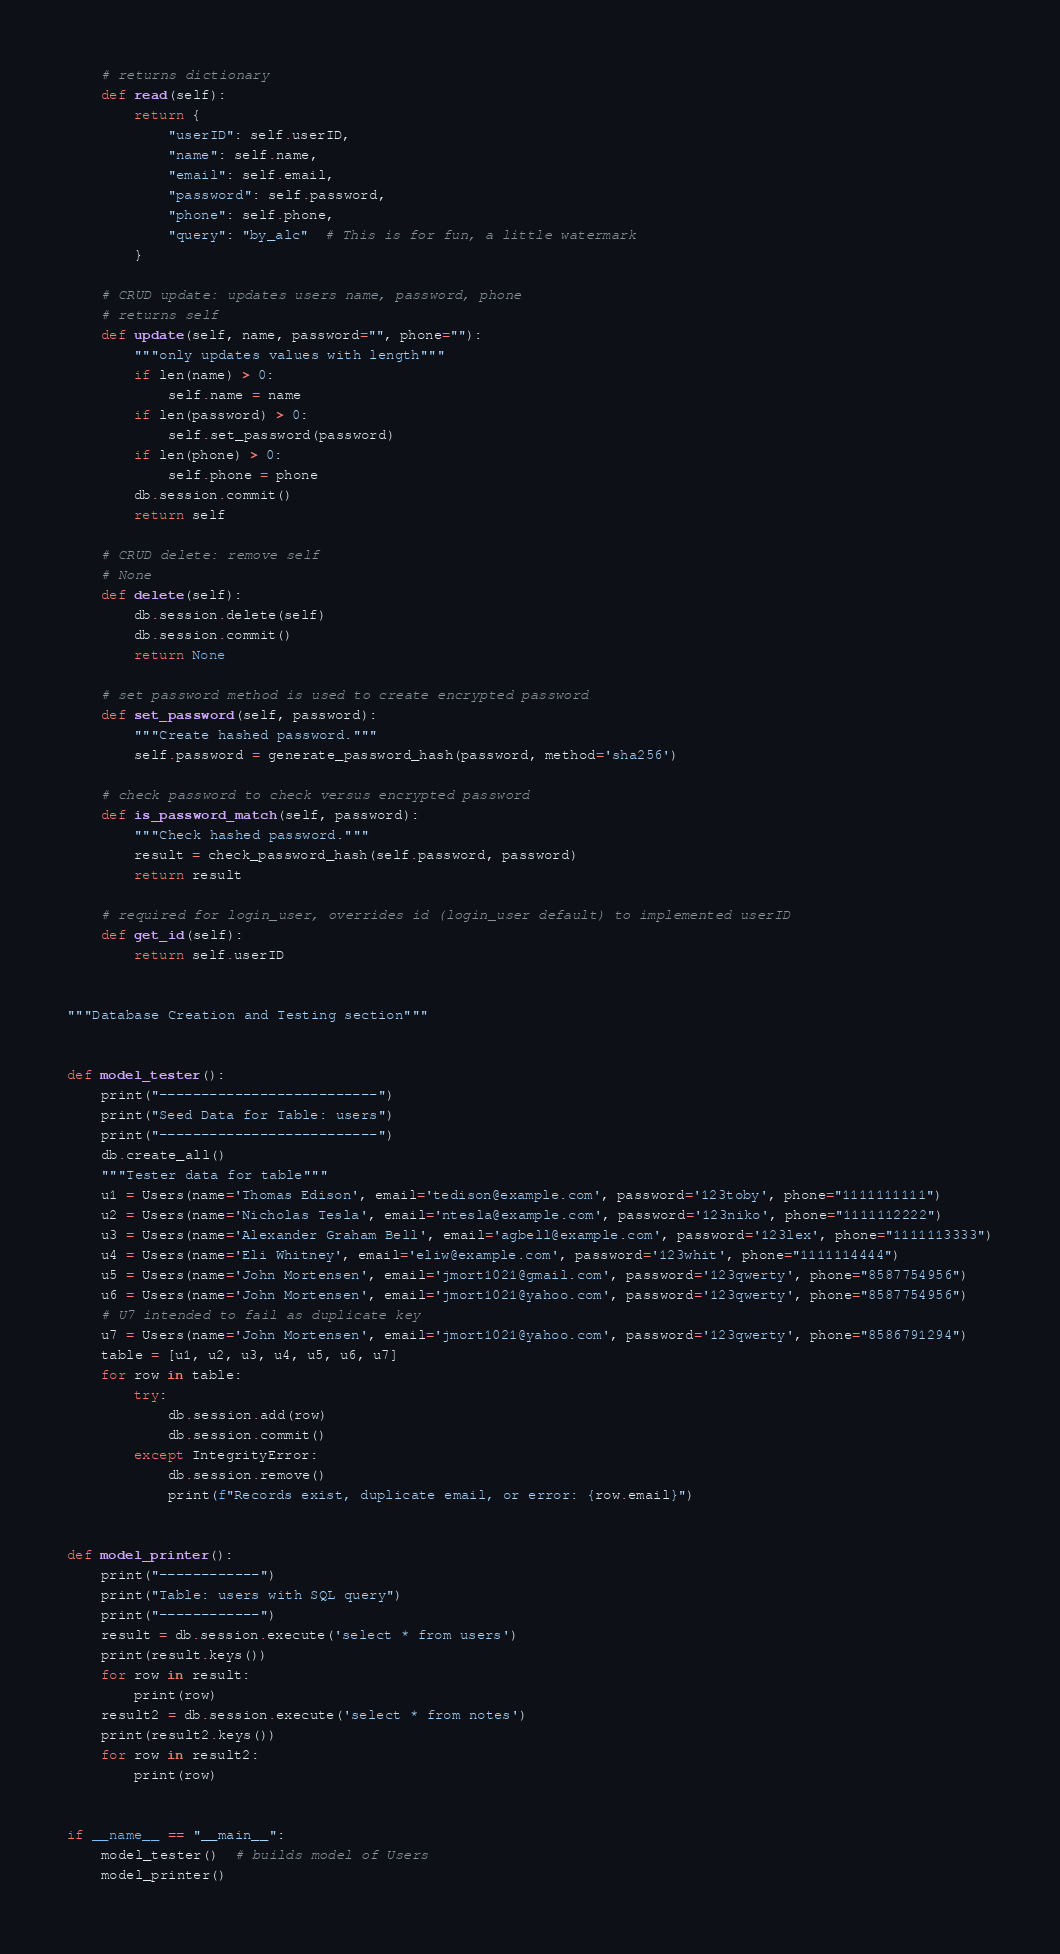Convert code to text. <code><loc_0><loc_0><loc_500><loc_500><_Python_>    # returns dictionary
    def read(self):
        return {
            "userID": self.userID,
            "name": self.name,
            "email": self.email,
            "password": self.password,
            "phone": self.phone,
            "query": "by_alc"  # This is for fun, a little watermark
        }

    # CRUD update: updates users name, password, phone
    # returns self
    def update(self, name, password="", phone=""):
        """only updates values with length"""
        if len(name) > 0:
            self.name = name
        if len(password) > 0:
            self.set_password(password)
        if len(phone) > 0:
            self.phone = phone
        db.session.commit()
        return self

    # CRUD delete: remove self
    # None
    def delete(self):
        db.session.delete(self)
        db.session.commit()
        return None

    # set password method is used to create encrypted password
    def set_password(self, password):
        """Create hashed password."""
        self.password = generate_password_hash(password, method='sha256')

    # check password to check versus encrypted password
    def is_password_match(self, password):
        """Check hashed password."""
        result = check_password_hash(self.password, password)
        return result

    # required for login_user, overrides id (login_user default) to implemented userID
    def get_id(self):
        return self.userID


"""Database Creation and Testing section"""


def model_tester():
    print("--------------------------")
    print("Seed Data for Table: users")
    print("--------------------------")
    db.create_all()
    """Tester data for table"""
    u1 = Users(name='Thomas Edison', email='tedison@example.com', password='123toby', phone="1111111111")
    u2 = Users(name='Nicholas Tesla', email='ntesla@example.com', password='123niko', phone="1111112222")
    u3 = Users(name='Alexander Graham Bell', email='agbell@example.com', password='123lex', phone="1111113333")
    u4 = Users(name='Eli Whitney', email='eliw@example.com', password='123whit', phone="1111114444")
    u5 = Users(name='John Mortensen', email='jmort1021@gmail.com', password='123qwerty', phone="8587754956")
    u6 = Users(name='John Mortensen', email='jmort1021@yahoo.com', password='123qwerty', phone="8587754956")
    # U7 intended to fail as duplicate key
    u7 = Users(name='John Mortensen', email='jmort1021@yahoo.com', password='123qwerty', phone="8586791294")
    table = [u1, u2, u3, u4, u5, u6, u7]
    for row in table:
        try:
            db.session.add(row)
            db.session.commit()
        except IntegrityError:
            db.session.remove()
            print(f"Records exist, duplicate email, or error: {row.email}")


def model_printer():
    print("------------")
    print("Table: users with SQL query")
    print("------------")
    result = db.session.execute('select * from users')
    print(result.keys())
    for row in result:
        print(row)
    result2 = db.session.execute('select * from notes')
    print(result2.keys())
    for row in result2:
        print(row)


if __name__ == "__main__":
    model_tester()  # builds model of Users
    model_printer()</code> 